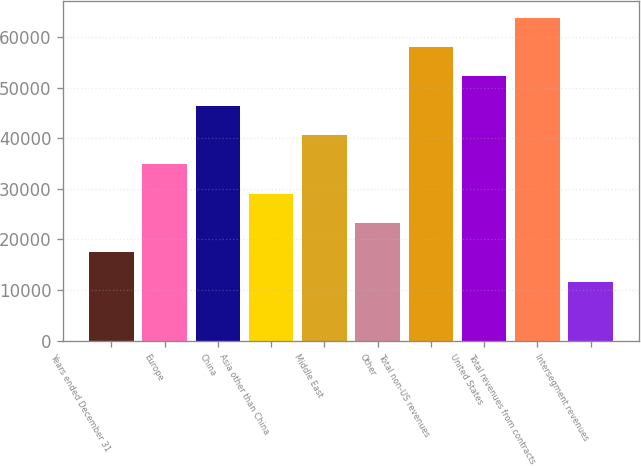Convert chart. <chart><loc_0><loc_0><loc_500><loc_500><bar_chart><fcel>Years ended December 31<fcel>Europe<fcel>China<fcel>Asia other than China<fcel>Middle East<fcel>Other<fcel>Total non-US revenues<fcel>United States<fcel>Total revenues from contracts<fcel>Intersegment revenues<nl><fcel>17470.7<fcel>34846.4<fcel>46430.2<fcel>29054.5<fcel>40638.3<fcel>23262.6<fcel>58014<fcel>52222.1<fcel>63805.9<fcel>11678.8<nl></chart> 